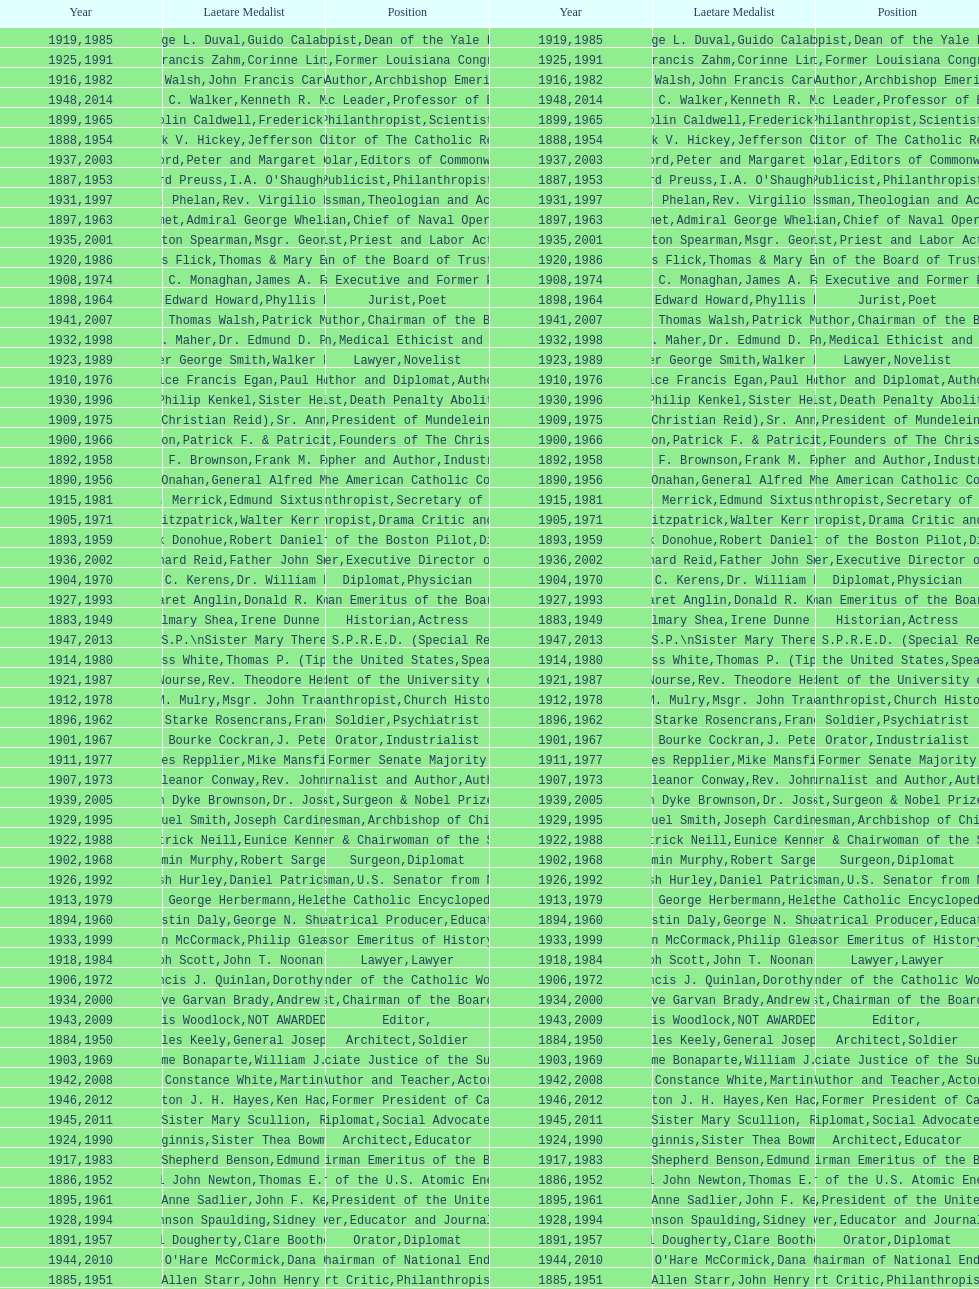Would you be able to parse every entry in this table? {'header': ['Year', 'Laetare Medalist', 'Position', 'Year', 'Laetare Medalist', 'Position'], 'rows': [['1919', 'George L. Duval', 'Philanthropist', '1985', 'Guido Calabresi', 'Dean of the Yale Law School'], ['1925', 'Albert Francis Zahm', 'Scientist', '1991', 'Corinne Lindy Boggs', 'Former Louisiana Congresswoman'], ['1916', 'James Joseph Walsh', 'Physician and Author', '1982', 'John Francis Cardinal Dearden', 'Archbishop Emeritus of Detroit'], ['1948', 'Frank C. Walker', 'Postmaster General and Civic Leader', '2014', 'Kenneth R. Miller', 'Professor of Biology at Brown University'], ['1899', 'Mary Gwendolin Caldwell', 'Philanthropist', '1965', 'Frederick D. Rossini', 'Scientist'], ['1888', 'Patrick V. Hickey', 'Founder and Editor of The Catholic Review', '1954', 'Jefferson Caffery', 'Diplomat'], ['1937', 'Jeremiah D. M. Ford', 'Scholar', '2003', "Peter and Margaret O'Brien Steinfels", 'Editors of Commonweal'], ['1887', 'Edward Preuss', 'Publicist', '1953', "I.A. O'Shaughnessy", 'Philanthropist'], ['1931', 'James J. Phelan', 'Businessman', '1997', 'Rev. Virgilio Elizondo', 'Theologian and Activist'], ['1897', 'Thomas Addis Emmet', 'Physician', '1963', 'Admiral George Whelan Anderson, Jr.', 'Chief of Naval Operations'], ['1935', 'Francis Hamilton Spearman', 'Novelist', '2001', 'Msgr. George G. Higgins', 'Priest and Labor Activist'], ['1920', 'Lawrence Francis Flick', 'Physician', '1986', 'Thomas & Mary Elizabeth Carney', 'Chairman of the Board of Trustees and his wife'], ['1908', 'James C. Monaghan', 'Economist', '1974', 'James A. Farley', 'Business Executive and Former Postmaster General'], ['1898', 'Timothy Edward Howard', 'Jurist', '1964', 'Phyllis McGinley', 'Poet'], ['1941', 'William Thomas Walsh', 'Journalist and Author', '2007', 'Patrick McCartan', 'Chairman of the Board of Trustees'], ['1932', 'Stephen J. Maher', 'Physician', '1998', 'Dr. Edmund D. Pellegrino', 'Medical Ethicist and Educator'], ['1923', 'Walter George Smith', 'Lawyer', '1989', 'Walker Percy', 'Novelist'], ['1910', 'Maurice Francis Egan', 'Author and Diplomat', '1976', 'Paul Horgan', 'Author'], ['1930', 'Frederick Philip Kenkel', 'Publicist', '1996', 'Sister Helen Prejean', 'Death Penalty Abolitionist'], ['1909', 'Frances Tieran (Christian Reid)', 'Novelist', '1975', 'Sr. Ann Ida Gannon, BMV', 'President of Mundelein College'], ['1900', 'John A. Creighton', 'Philanthropist', '1966', 'Patrick F. & Patricia Caron Crowley', 'Founders of The Christian Movement'], ['1892', 'Henry F. Brownson', 'Philosopher and Author', '1958', 'Frank M. Folsom', 'Industrialist'], ['1890', 'William J. Onahan', 'Organizer of the American Catholic Congress', '1956', 'General Alfred M. Gruenther', 'Soldier'], ['1915', 'Mary V. Merrick', 'Philanthropist', '1981', 'Edmund Sixtus Muskie', 'Secretary of State'], ['1905', 'Thomas B. Fitzpatrick', 'Philanthropist', '1971', 'Walter Kerr & Jean Kerr', 'Drama Critic and Author'], ['1893', 'Patrick Donohue', 'Founder of the Boston Pilot', '1959', 'Robert Daniel Murphy', 'Diplomat'], ['1936', 'Richard Reid', 'Journalist and Lawyer', '2002', 'Father John Smyth', 'Executive Director of Maryville Academy'], ['1904', 'Richard C. Kerens', 'Diplomat', '1970', 'Dr. William B. Walsh', 'Physician'], ['1927', 'Margaret Anglin', 'Actress', '1993', 'Donald R. Keough', 'Chairman Emeritus of the Board of Trustees'], ['1883', 'John Gilmary Shea', 'Historian', '1949', 'Irene Dunne Griffin', 'Actress'], ['1947', 'William G. Bruce', 'Publisher and Civic Leader', '2013', 'Sister Susanne Gallagher, S.P.\\nSister Mary Therese Harrington, S.H.\\nRev. James H. McCarthy', 'Founders of S.P.R.E.D. (Special Religious Education Development Network)'], ['1914', 'Edward Douglass White', 'Chief Justice of the United States', '1980', "Thomas P. (Tip) O'Neill Jr.", 'Speaker of the House'], ['1921', 'Elizabeth Nourse', 'Artist', '1987', 'Rev. Theodore Hesburgh, CSC', 'President of the University of Notre Dame'], ['1912', 'Thomas M. Mulry', 'Philanthropist', '1978', 'Msgr. John Tracy Ellis', 'Church Historian'], ['1896', 'General William Starke Rosencrans', 'Soldier', '1962', 'Francis J. Braceland', 'Psychiatrist'], ['1901', 'William Bourke Cockran', 'Orator', '1967', 'J. Peter Grace', 'Industrialist'], ['1911', 'Agnes Repplier', 'Author', '1977', 'Mike Mansfield', 'Former Senate Majority Leader'], ['1907', 'Katherine Eleanor Conway', 'Journalist and Author', '1973', "Rev. John A. O'Brien", 'Author'], ['1939', 'Josephine Van Dyke Brownson', 'Catechist', '2005', 'Dr. Joseph E. Murray', 'Surgeon & Nobel Prize Winner'], ['1929', 'Alfred Emmanuel Smith', 'Statesman', '1995', 'Joseph Cardinal Bernardin', 'Archbishop of Chicago'], ['1922', 'Charles Patrick Neill', 'Economist', '1988', 'Eunice Kennedy Shriver', 'Founder & Chairwoman of the Special Olympics'], ['1902', 'John Benjamin Murphy', 'Surgeon', '1968', 'Robert Sargent Shriver', 'Diplomat'], ['1926', 'Edward Nash Hurley', 'Businessman', '1992', 'Daniel Patrick Moynihan', 'U.S. Senator from New York'], ['1913', 'Charles George Herbermann', 'Editor of the Catholic Encyclopedia', '1979', 'Helen Hayes', 'Actress'], ['1894', 'Augustin Daly', 'Theatrical Producer', '1960', 'George N. Shuster', 'Educator'], ['1933', 'John McCormack', 'Artist', '1999', 'Philip Gleason', 'Professor Emeritus of History, Notre Dame'], ['1918', 'Joseph Scott', 'Lawyer', '1984', 'John T. Noonan, Jr.', 'Lawyer'], ['1906', 'Francis J. Quinlan', 'Physician', '1972', 'Dorothy Day', 'Founder of the Catholic Worker Movement'], ['1934', 'Genevieve Garvan Brady', 'Philanthropist', '2000', 'Andrew McKenna', 'Chairman of the Board of Trustees'], ['1943', 'Thomas Francis Woodlock', 'Editor', '2009', 'NOT AWARDED (SEE BELOW)', ''], ['1884', 'Patrick Charles Keely', 'Architect', '1950', 'General Joseph L. Collins', 'Soldier'], ['1903', 'Charles Jerome Bonaparte', 'Lawyer', '1969', 'William J. Brennan Jr.', 'Associate Justice of the Supreme Court'], ['1942', 'Helen Constance White', 'Author and Teacher', '2008', 'Martin Sheen', 'Actor'], ['1946', 'Carlton J. H. Hayes', 'Historian and Diplomat', '2012', 'Ken Hackett', 'Former President of Catholic Relief Services'], ['1945', 'Gardiner Howland Shaw', 'Diplomat', '2011', 'Sister Mary Scullion, R.S.M., & Joan McConnon', 'Social Advocates'], ['1924', 'Charles Donagh Maginnis', 'Architect', '1990', 'Sister Thea Bowman (posthumously)', 'Educator'], ['1917', 'Admiral William Shepherd Benson', 'Chief of Naval Operations', '1983', 'Edmund & Evelyn Stephan', 'Chairman Emeritus of the Board of Trustees and his wife'], ['1886', 'General John Newton', 'Engineer', '1952', 'Thomas E. Murray', 'Member of the U.S. Atomic Energy Commission'], ['1895', 'Mary Anne Sadlier', 'Novelist', '1961', 'John F. Kennedy', 'President of the United States'], ['1928', 'John Johnson Spaulding', 'Lawyer', '1994', 'Sidney Callahan', 'Educator and Journalist'], ['1891', 'Daniel Dougherty', 'Orator', '1957', 'Clare Boothe Luce', 'Diplomat'], ['1944', "Anne O'Hare McCormick", 'Journalist', '2010', 'Dana Gioia', 'Former Chairman of National Endowment for the Arts'], ['1885', 'Eliza Allen Starr', 'Art Critic', '1951', 'John Henry Phelan', 'Philanthropist'], ['1938', 'Irvin William Abell', 'Surgeon', '2004', 'Father J. Bryan Hehir', 'President of Catholic Charities, Archdiocese of Boston'], ['1889', 'Anna Hanson Dorsey', 'Novelist', '1955', 'George Meany', 'Labor Leader'], ['1940', 'General Hugh Aloysius Drum', 'Soldier', '2006', 'Dave Brubeck', 'Jazz Pianist']]} What's the count of people who are or were journalists? 5. 